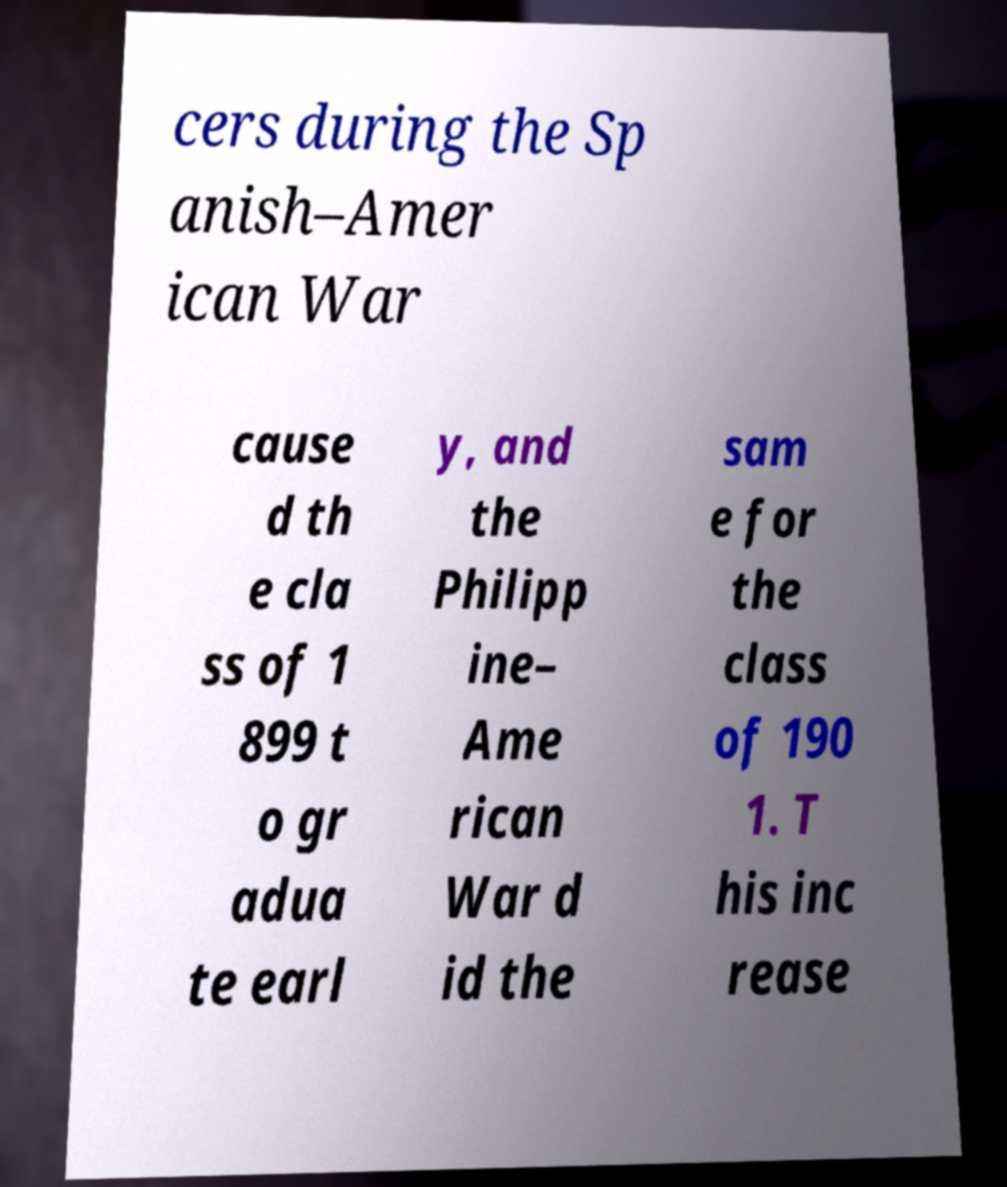Please read and relay the text visible in this image. What does it say? cers during the Sp anish–Amer ican War cause d th e cla ss of 1 899 t o gr adua te earl y, and the Philipp ine– Ame rican War d id the sam e for the class of 190 1. T his inc rease 